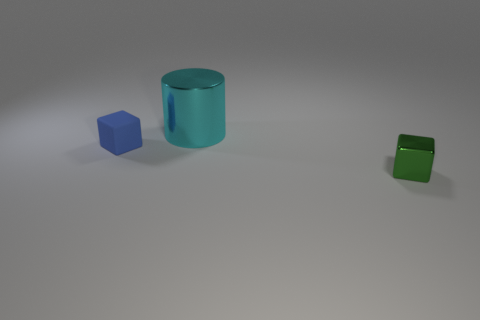Subtract all cylinders. How many objects are left? 2 Add 1 rubber objects. How many objects exist? 4 Add 1 green things. How many green things are left? 2 Add 1 cylinders. How many cylinders exist? 2 Subtract 1 green blocks. How many objects are left? 2 Subtract all small purple metallic objects. Subtract all rubber blocks. How many objects are left? 2 